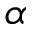<formula> <loc_0><loc_0><loc_500><loc_500>\alpha</formula> 